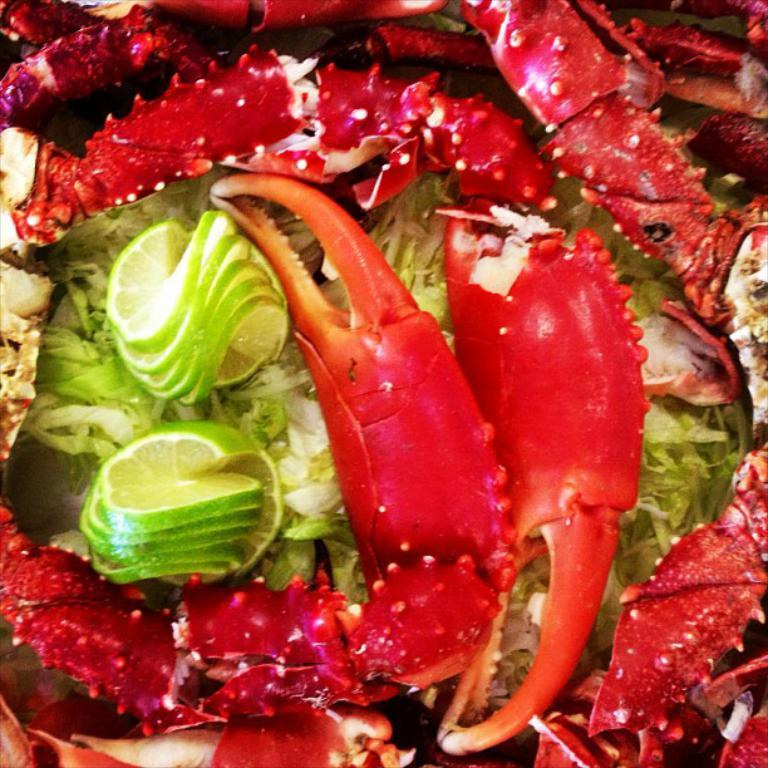What type of food can be seen in the image? There are pieces of crabs in the image. What color are the crabs? The crabs are red in color. What is another food item present in the image? There is a lemon in the image. What is used as a garnish in the image? There is cabbage garnish in the image. Can you see a print of a kitten on the crab shells in the image? There is no print of a kitten on the crab shells in the image. Is there a trail of footprints leading to the crabs in the image? There is no trail of footprints visible in the image. 